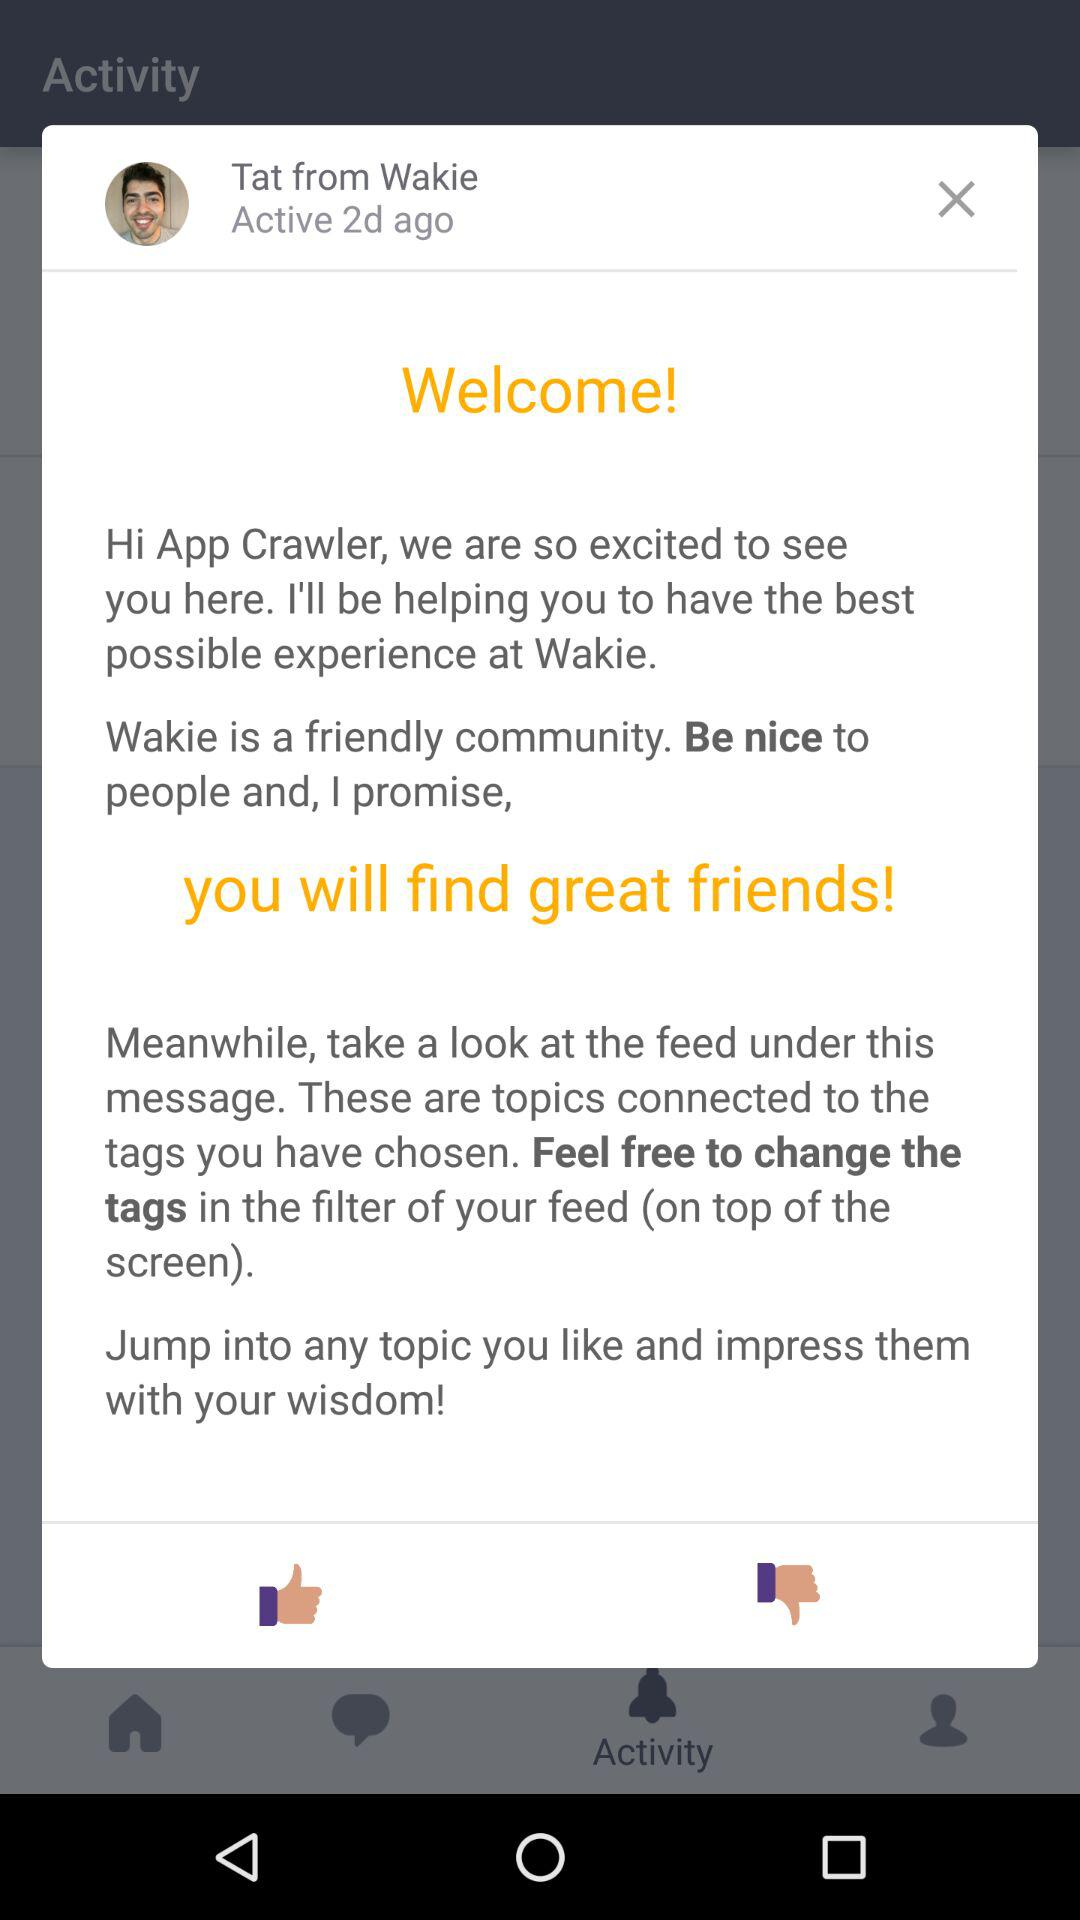What is the name of the user? The name of the user is App Crawler. 